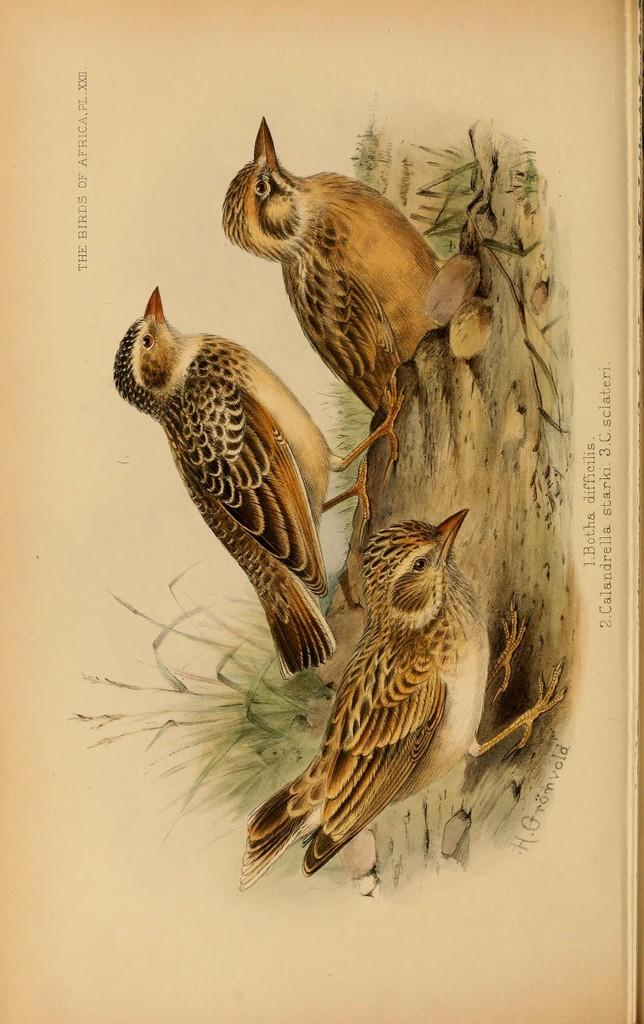What type of animals are depicted in the images? There are pictures of birds in the image. What else can be seen in the image besides the bird pictures? There is text surrounding the bird pictures. Reasoning: Let' Let's think step by step in order to produce the conversation. We start by identifying the main subject of the image, which is the pictures of birds. Then, we expand the conversation to include the text surrounding the bird pictures, as mentioned in the facts. We ensure that each question can be answered definitively with the information given and avoid yes/no questions. Absurd Question/Answer: What type of shoe can be seen in the image? There is no shoe present in the image; it features pictures of birds and text. How many trains are visible in the image? There are no trains visible in the image; it only contains pictures of birds and text. What type of gate can be seen in the image? There is no gate present in the image; it features pictures of birds and text. 